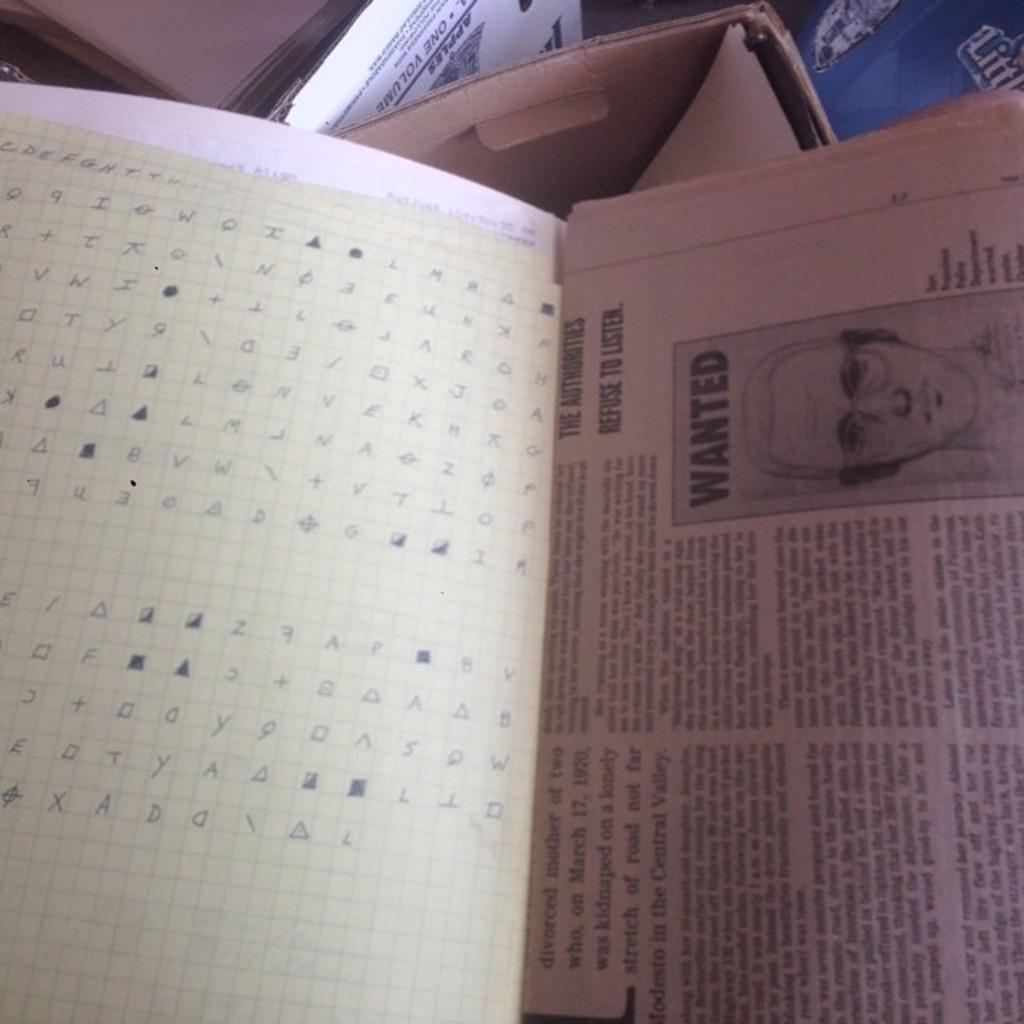What is on that page?
Offer a terse response. Wanted poster. 